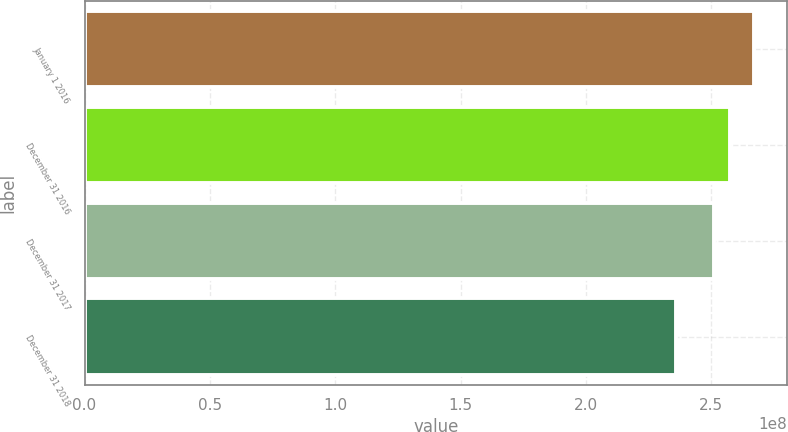Convert chart to OTSL. <chart><loc_0><loc_0><loc_500><loc_500><bar_chart><fcel>January 1 2016<fcel>December 31 2016<fcel>December 31 2017<fcel>December 31 2018<nl><fcel>2.66876e+08<fcel>2.5733e+08<fcel>2.51174e+08<fcel>2.35861e+08<nl></chart> 